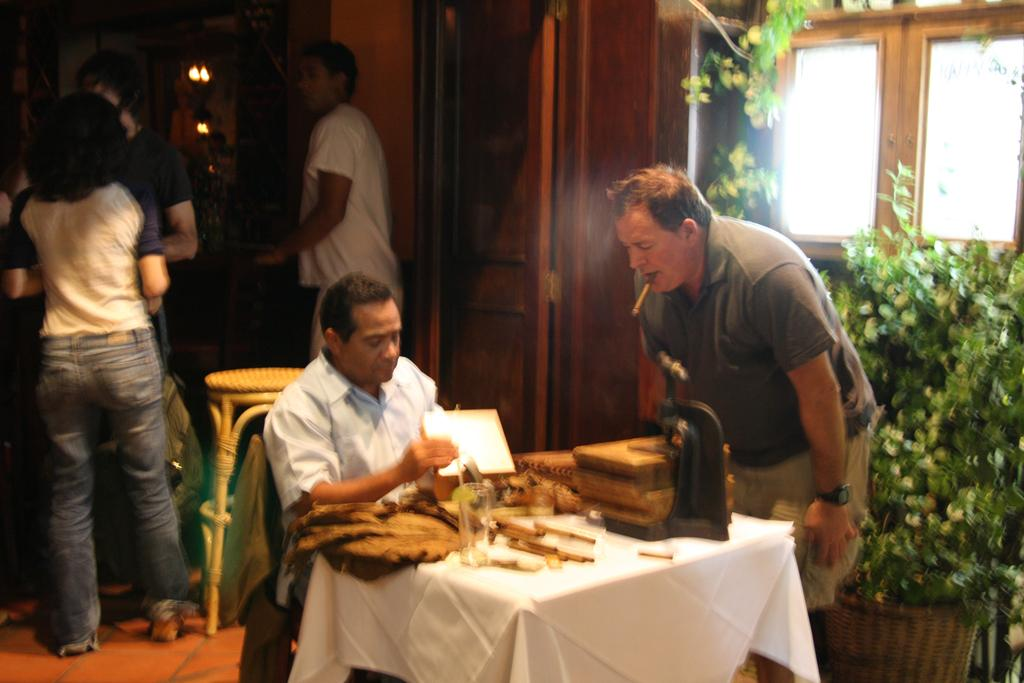What are the people in the image doing? The people in the image are standing. Can you describe the position of one of the people in the image? There is a person sitting on a table in the image. What can be seen in the background of the image? There are plants visible in the background of the image. What type of mitten is the person wearing in the image? There is no mitten visible in the image. How many pages are in the book that the person is reading in the image? There is no book or page visible in the image. 